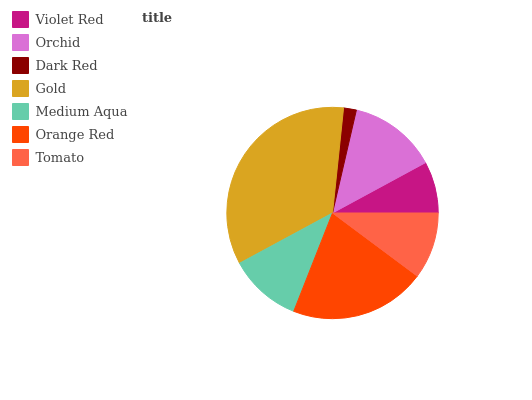Is Dark Red the minimum?
Answer yes or no. Yes. Is Gold the maximum?
Answer yes or no. Yes. Is Orchid the minimum?
Answer yes or no. No. Is Orchid the maximum?
Answer yes or no. No. Is Orchid greater than Violet Red?
Answer yes or no. Yes. Is Violet Red less than Orchid?
Answer yes or no. Yes. Is Violet Red greater than Orchid?
Answer yes or no. No. Is Orchid less than Violet Red?
Answer yes or no. No. Is Medium Aqua the high median?
Answer yes or no. Yes. Is Medium Aqua the low median?
Answer yes or no. Yes. Is Gold the high median?
Answer yes or no. No. Is Tomato the low median?
Answer yes or no. No. 